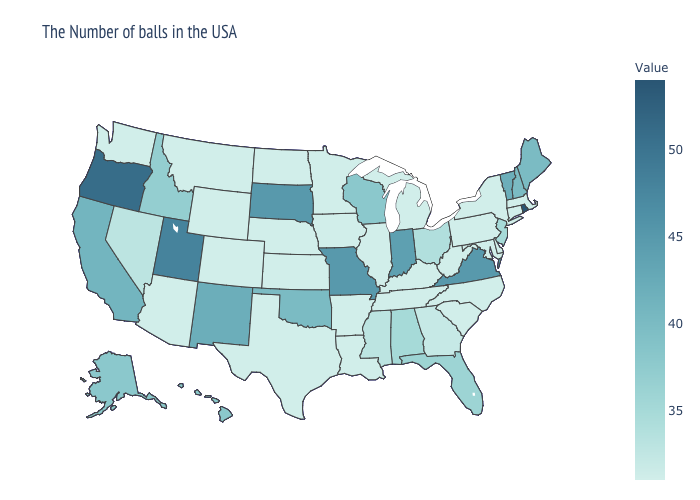Does Wyoming have the highest value in the West?
Be succinct. No. Among the states that border Kansas , does Missouri have the lowest value?
Give a very brief answer. No. Does Arkansas have a lower value than Virginia?
Quick response, please. Yes. 